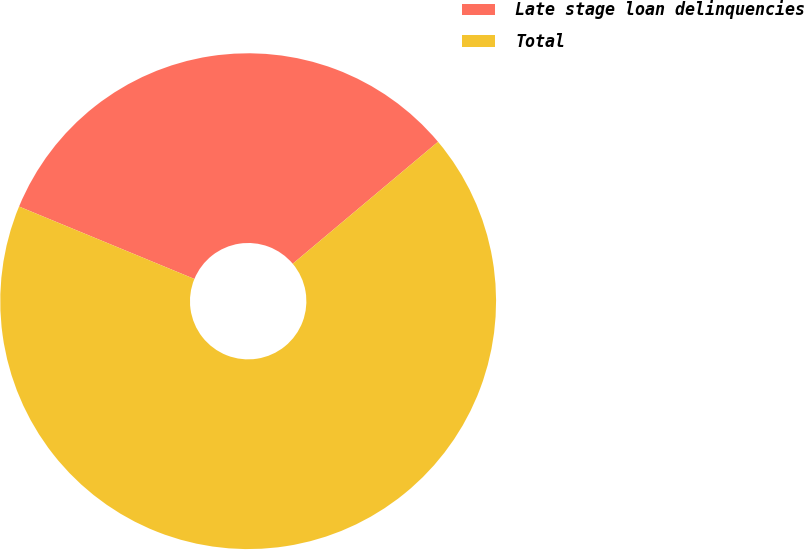Convert chart. <chart><loc_0><loc_0><loc_500><loc_500><pie_chart><fcel>Late stage loan delinquencies<fcel>Total<nl><fcel>32.65%<fcel>67.35%<nl></chart> 